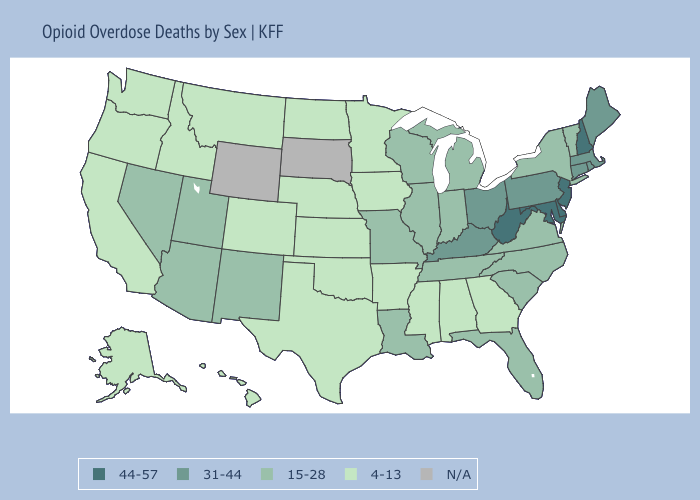What is the value of Idaho?
Concise answer only. 4-13. What is the highest value in the USA?
Answer briefly. 44-57. What is the lowest value in the USA?
Concise answer only. 4-13. Does Oklahoma have the lowest value in the South?
Be succinct. Yes. Which states have the highest value in the USA?
Concise answer only. Delaware, Maryland, New Hampshire, New Jersey, West Virginia. Does Florida have the lowest value in the USA?
Write a very short answer. No. Which states have the lowest value in the USA?
Keep it brief. Alabama, Alaska, Arkansas, California, Colorado, Georgia, Hawaii, Idaho, Iowa, Kansas, Minnesota, Mississippi, Montana, Nebraska, North Dakota, Oklahoma, Oregon, Texas, Washington. Does the first symbol in the legend represent the smallest category?
Be succinct. No. Which states hav the highest value in the West?
Give a very brief answer. Arizona, Nevada, New Mexico, Utah. Which states have the highest value in the USA?
Write a very short answer. Delaware, Maryland, New Hampshire, New Jersey, West Virginia. What is the lowest value in the MidWest?
Short answer required. 4-13. Among the states that border Utah , which have the lowest value?
Concise answer only. Colorado, Idaho. Name the states that have a value in the range 31-44?
Be succinct. Connecticut, Kentucky, Maine, Massachusetts, Ohio, Pennsylvania, Rhode Island. 